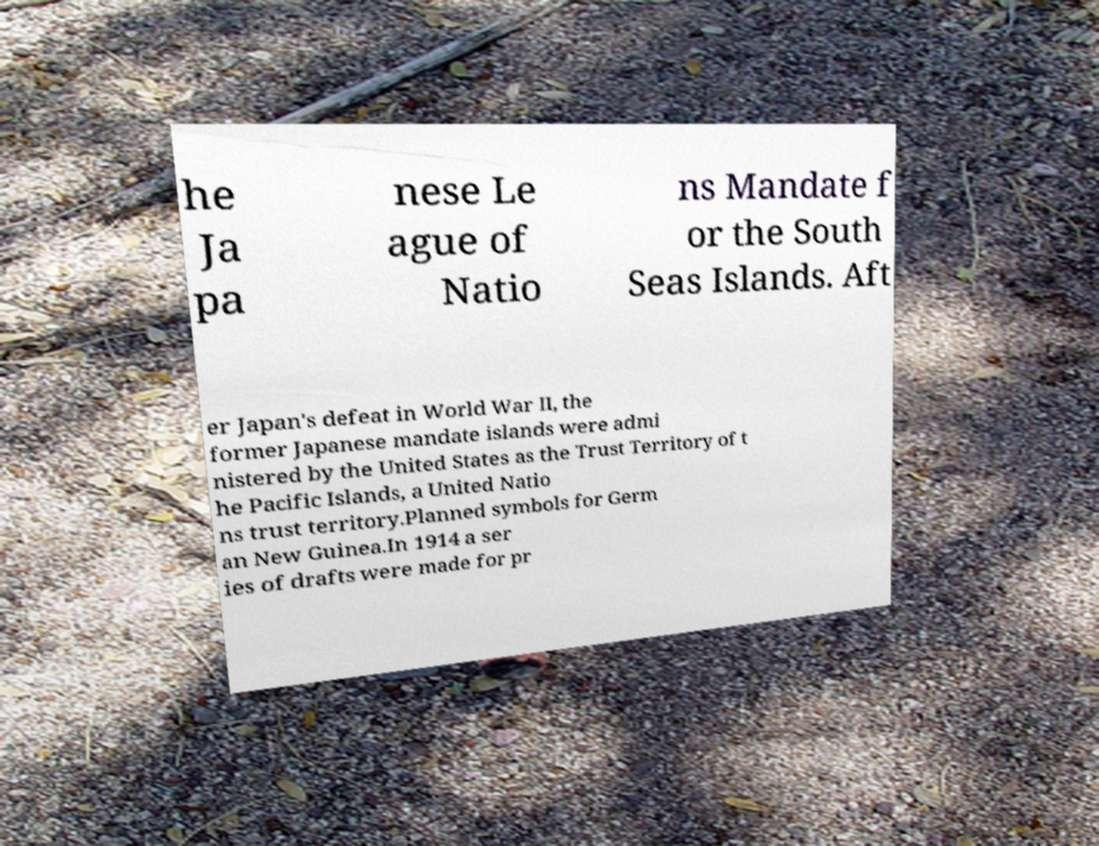I need the written content from this picture converted into text. Can you do that? he Ja pa nese Le ague of Natio ns Mandate f or the South Seas Islands. Aft er Japan's defeat in World War II, the former Japanese mandate islands were admi nistered by the United States as the Trust Territory of t he Pacific Islands, a United Natio ns trust territory.Planned symbols for Germ an New Guinea.In 1914 a ser ies of drafts were made for pr 